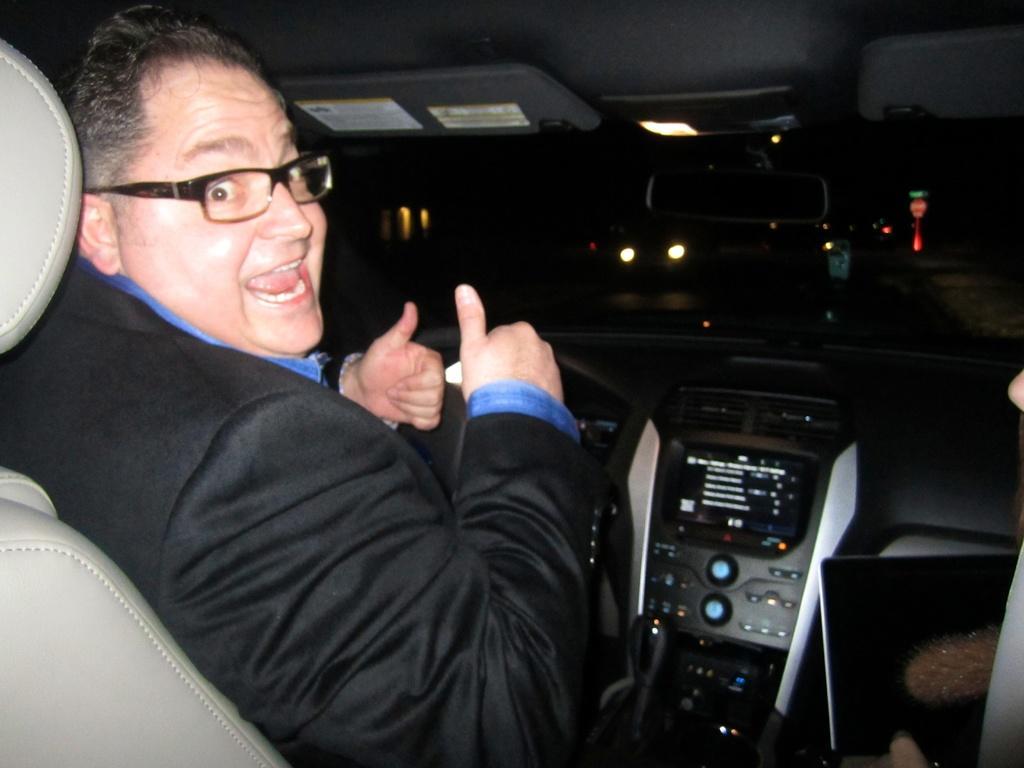Describe this image in one or two sentences. In this image I can see a man is sitting in a car. I can see he is wearing a specs. On the road I can see few more vehicle. 